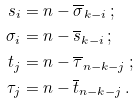Convert formula to latex. <formula><loc_0><loc_0><loc_500><loc_500>s _ { i } & = n - \overline { \sigma } _ { k - i } \, ; \\ \sigma _ { i } & = n - \overline { s } _ { k - i } \, ; \\ t _ { j } & = n - \overline { \tau } _ { n - k - j } \, ; \\ \tau _ { j } & = n - \overline { t } _ { n - k - j } \, .</formula> 